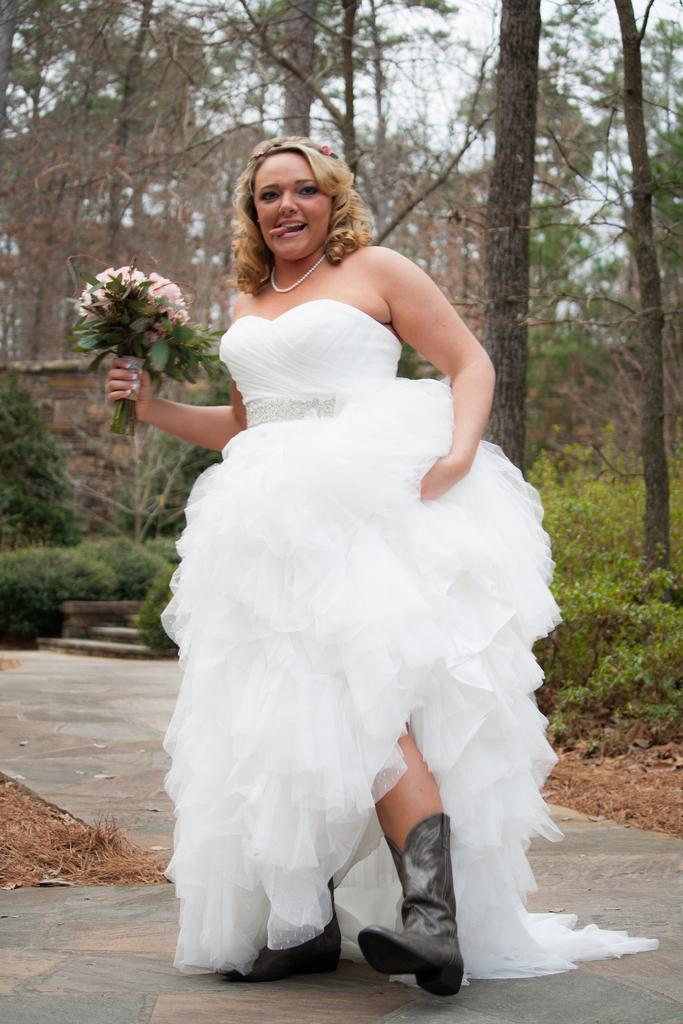Who is the main subject in the image? There is a lady in the image. What is the lady wearing? The lady is wearing a white dress. What is the lady doing in the image? The lady is standing and holding a flower bouquet. What can be seen in the background of the image? There are plants and trees in the background of the image. What type of prison can be seen in the background of the image? There is no prison present in the image; it features a lady in a white dress holding a flower bouquet, with plants and trees in the background. 